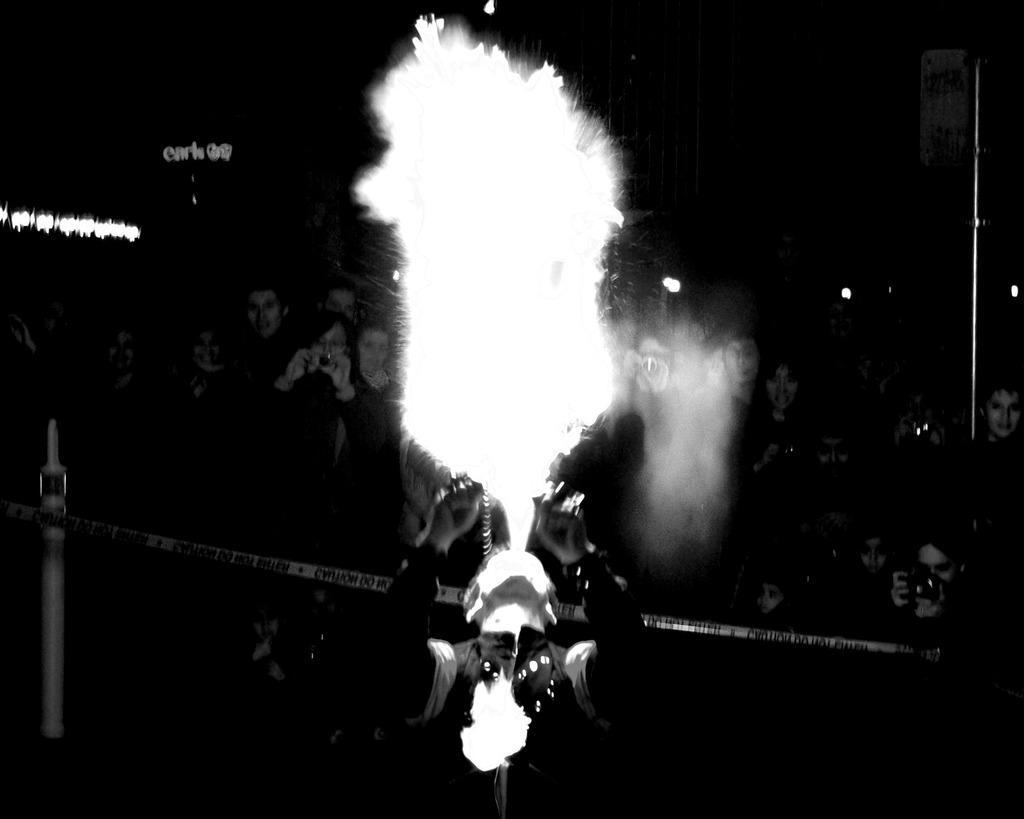Describe this image in one or two sentences. It is a black and white picture. At the bottom of the image, we can see a person. Here there is a caution tape and pole. Background we can see a group of people. Few people are holding cameras. Top of the image, we can see dark view, lights, pole, board and some text. 